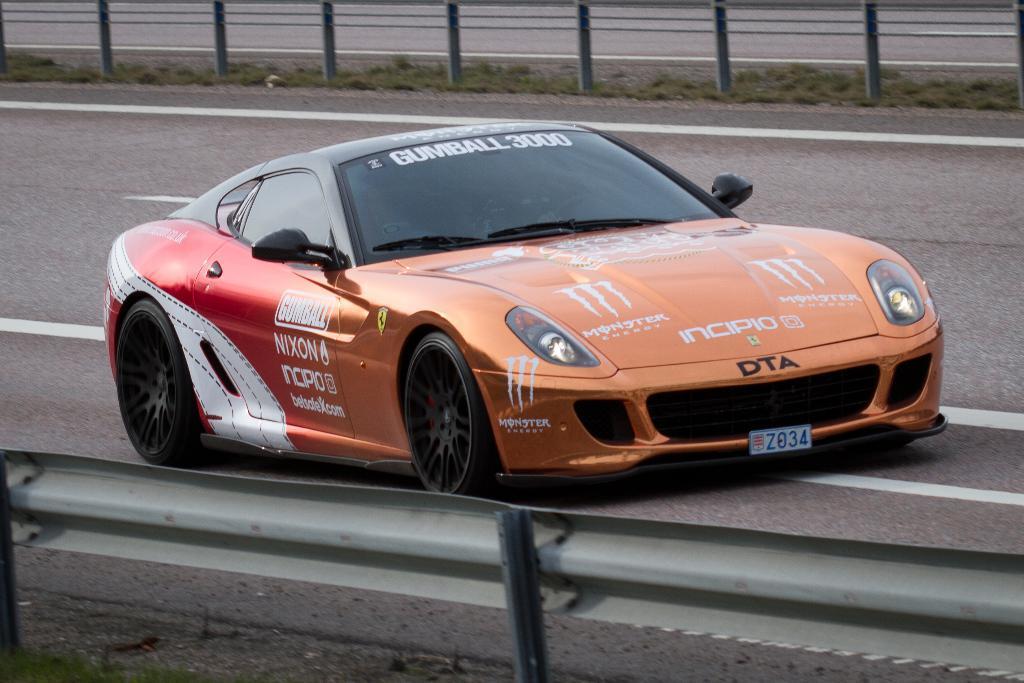Could you give a brief overview of what you see in this image? In the center of the image we can see one car on the road. And we can see some text on the car. At the bottom of the image, there is a fence and grass. In the background we can see the grass, road and fence. 